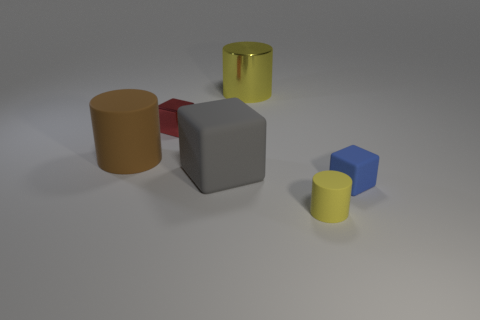There is a large cylinder that is behind the small shiny thing; is it the same color as the tiny matte cylinder?
Ensure brevity in your answer.  Yes. Does the shiny object that is right of the gray cube have the same color as the rubber cylinder that is right of the big matte cylinder?
Your answer should be very brief. Yes. What is the material of the cylinder that is the same color as the large metal thing?
Ensure brevity in your answer.  Rubber. There is a yellow thing that is in front of the brown object; is its shape the same as the metal thing in front of the metallic cylinder?
Ensure brevity in your answer.  No. What number of red objects are behind the small red object?
Ensure brevity in your answer.  0. Are there any big gray things that have the same material as the large brown object?
Provide a succinct answer. Yes. What material is the other cylinder that is the same size as the brown rubber cylinder?
Offer a terse response. Metal. Are the big brown cylinder and the small red object made of the same material?
Provide a succinct answer. No. How many things are large gray shiny things or small red metallic blocks?
Give a very brief answer. 1. What shape is the big object behind the small red block?
Keep it short and to the point. Cylinder. 